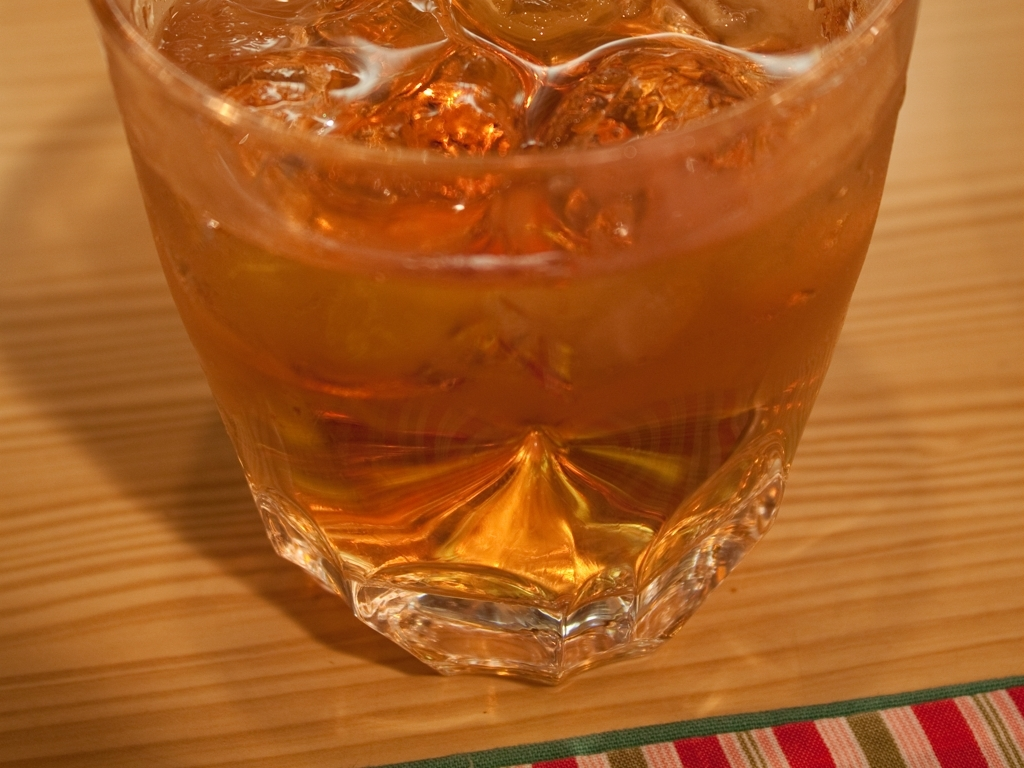Describe the setting in which this glass is placed. What does it suggest about how the beverage might be enjoyed? The glass cup sits on a wooden table with a visible grain pattern, suggesting a warm, casual setting such as a home, cafe, or a picnic. The use of a glass cup, as opposed to disposable or plastic ware, implies a moment of relaxation and leisure, where one can take the time to appreciate their drink. The fabric under the glass hints at attention to presentation, possibly indicating a meal or social gathering. 